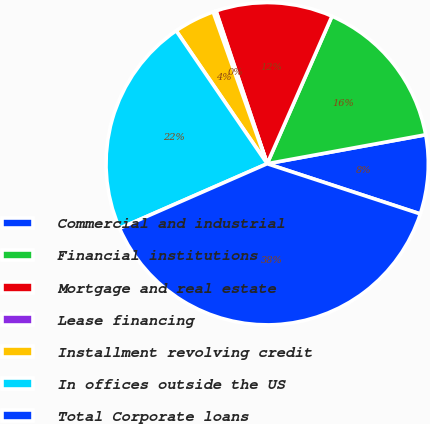Convert chart. <chart><loc_0><loc_0><loc_500><loc_500><pie_chart><fcel>Commercial and industrial<fcel>Financial institutions<fcel>Mortgage and real estate<fcel>Lease financing<fcel>Installment revolving credit<fcel>In offices outside the US<fcel>Total Corporate loans<nl><fcel>7.92%<fcel>15.54%<fcel>11.73%<fcel>0.3%<fcel>4.11%<fcel>22.02%<fcel>38.39%<nl></chart> 